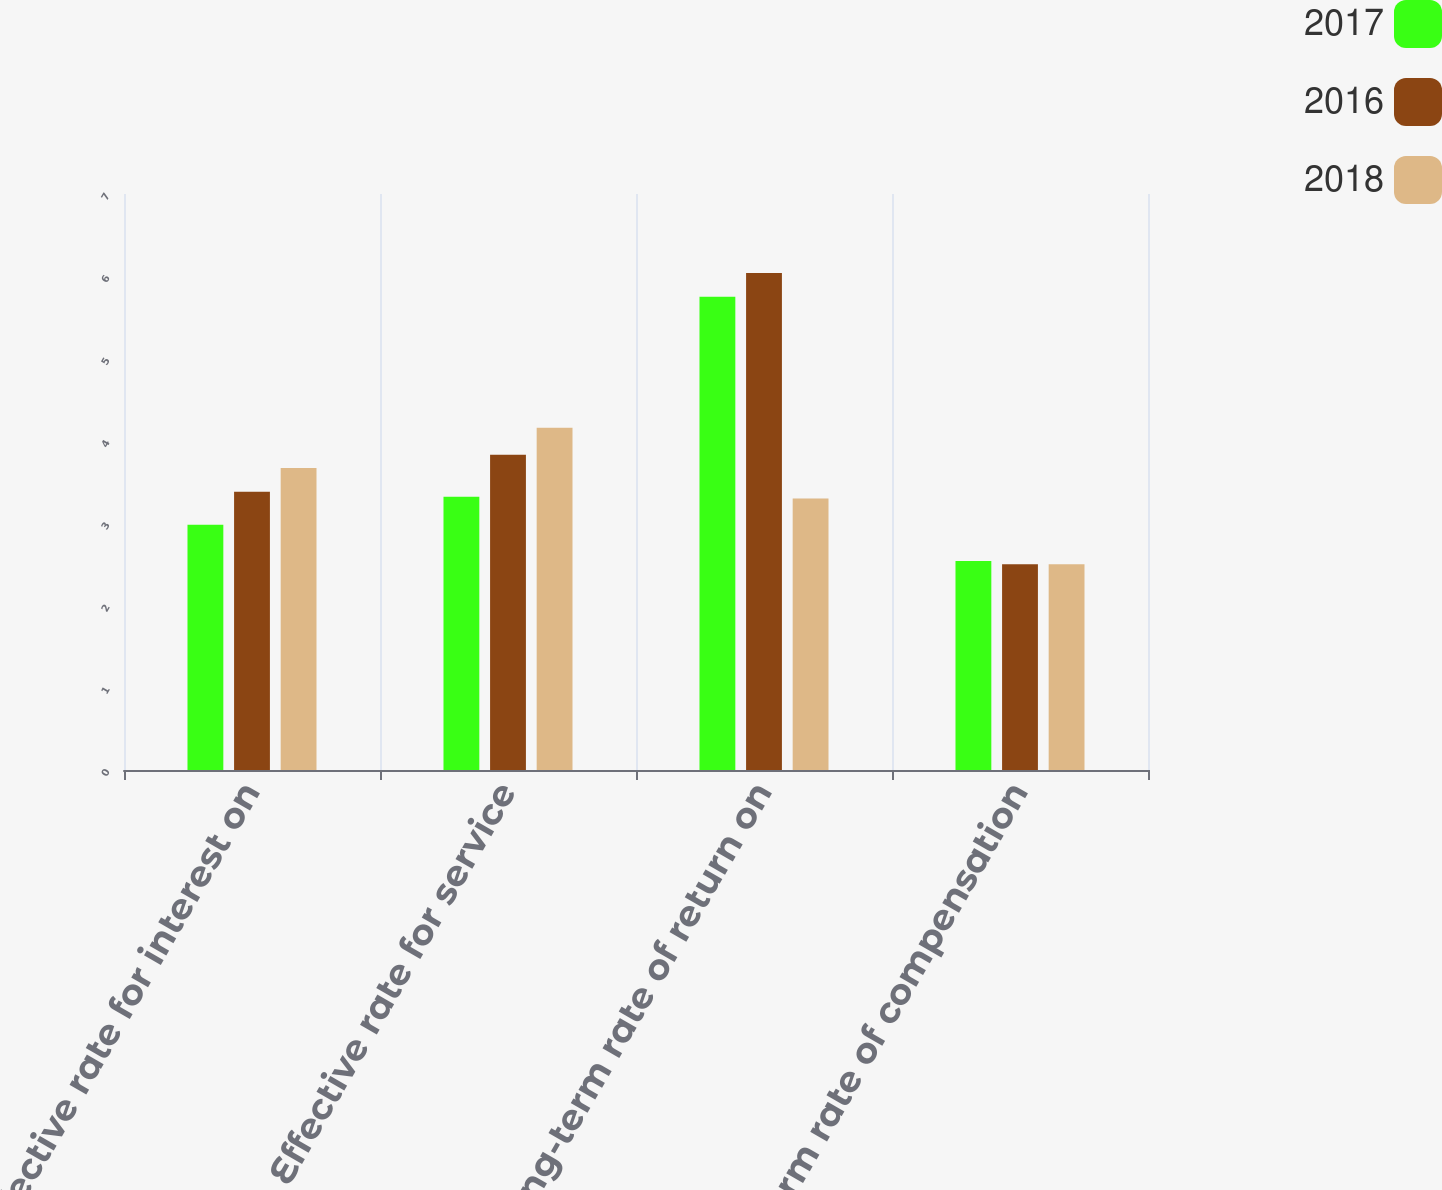Convert chart. <chart><loc_0><loc_0><loc_500><loc_500><stacked_bar_chart><ecel><fcel>Effective rate for interest on<fcel>Effective rate for service<fcel>Long-term rate of return on<fcel>Long-term rate of compensation<nl><fcel>2017<fcel>2.98<fcel>3.32<fcel>5.75<fcel>2.54<nl><fcel>2016<fcel>3.38<fcel>3.83<fcel>6.04<fcel>2.5<nl><fcel>2018<fcel>3.67<fcel>4.16<fcel>3.3<fcel>2.5<nl></chart> 